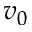<formula> <loc_0><loc_0><loc_500><loc_500>v _ { 0 }</formula> 